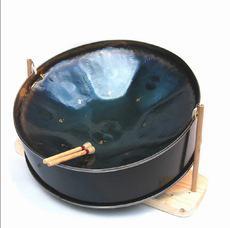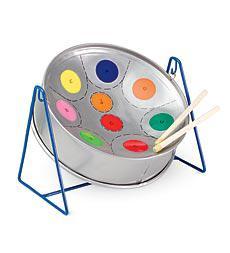The first image is the image on the left, the second image is the image on the right. Examine the images to the left and right. Is the description "All the drums are blue." accurate? Answer yes or no. No. 